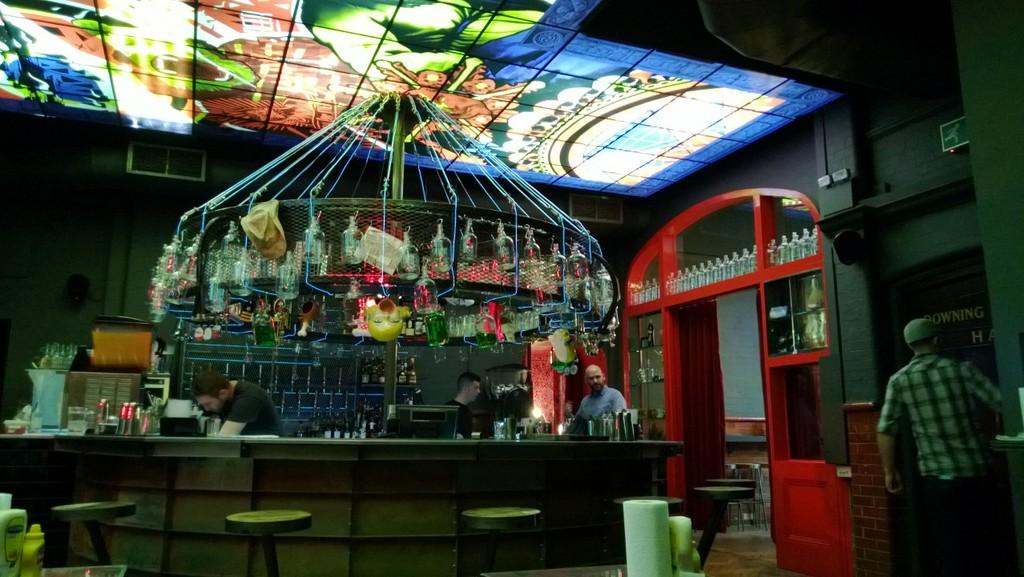What type of setting is depicted in the image? The image appears to depict a bar setting. Can you describe the main subject in the image? There is a man standing in the middle of the image. What can be seen in the background of the image? Wine bottles are present in racks in the background. Are there any other people visible in the image? Yes, there is a man walking on the right side of the image. What type of coil is being used to push the man walking on the right side of the image? There is no coil or pushing force visible in the image; the man is walking on his own. How many people are in the crowd in the image? There is no crowd present in the image; it only shows two men in a bar setting. 